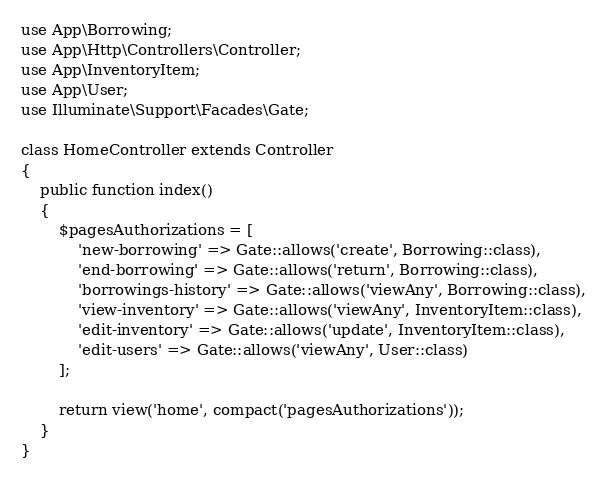Convert code to text. <code><loc_0><loc_0><loc_500><loc_500><_PHP_>use App\Borrowing;
use App\Http\Controllers\Controller;
use App\InventoryItem;
use App\User;
use Illuminate\Support\Facades\Gate;

class HomeController extends Controller
{
    public function index()
    {
        $pagesAuthorizations = [
            'new-borrowing' => Gate::allows('create', Borrowing::class),
            'end-borrowing' => Gate::allows('return', Borrowing::class),
            'borrowings-history' => Gate::allows('viewAny', Borrowing::class),
            'view-inventory' => Gate::allows('viewAny', InventoryItem::class),
            'edit-inventory' => Gate::allows('update', InventoryItem::class),
            'edit-users' => Gate::allows('viewAny', User::class)
        ];

        return view('home', compact('pagesAuthorizations'));
    }
}
</code> 